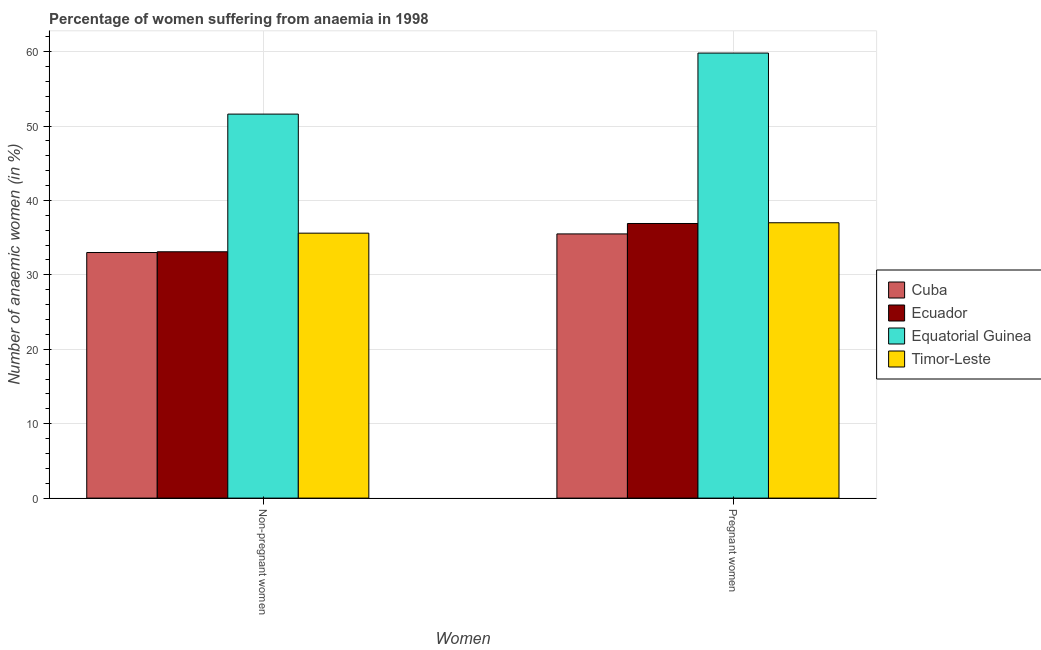How many different coloured bars are there?
Ensure brevity in your answer.  4. How many groups of bars are there?
Provide a succinct answer. 2. Are the number of bars per tick equal to the number of legend labels?
Offer a terse response. Yes. How many bars are there on the 1st tick from the right?
Your answer should be compact. 4. What is the label of the 2nd group of bars from the left?
Give a very brief answer. Pregnant women. Across all countries, what is the maximum percentage of non-pregnant anaemic women?
Provide a succinct answer. 51.6. Across all countries, what is the minimum percentage of non-pregnant anaemic women?
Keep it short and to the point. 33. In which country was the percentage of pregnant anaemic women maximum?
Make the answer very short. Equatorial Guinea. In which country was the percentage of non-pregnant anaemic women minimum?
Your response must be concise. Cuba. What is the total percentage of non-pregnant anaemic women in the graph?
Offer a very short reply. 153.3. What is the difference between the percentage of pregnant anaemic women in Ecuador and that in Timor-Leste?
Provide a succinct answer. -0.1. What is the difference between the percentage of pregnant anaemic women in Equatorial Guinea and the percentage of non-pregnant anaemic women in Ecuador?
Your answer should be compact. 26.7. What is the average percentage of pregnant anaemic women per country?
Provide a short and direct response. 42.3. What is the difference between the percentage of non-pregnant anaemic women and percentage of pregnant anaemic women in Timor-Leste?
Your answer should be compact. -1.4. What is the ratio of the percentage of non-pregnant anaemic women in Equatorial Guinea to that in Ecuador?
Make the answer very short. 1.56. What does the 2nd bar from the left in Pregnant women represents?
Keep it short and to the point. Ecuador. What does the 4th bar from the right in Non-pregnant women represents?
Provide a short and direct response. Cuba. How many countries are there in the graph?
Keep it short and to the point. 4. What is the difference between two consecutive major ticks on the Y-axis?
Provide a short and direct response. 10. Does the graph contain grids?
Offer a terse response. Yes. Where does the legend appear in the graph?
Ensure brevity in your answer.  Center right. How many legend labels are there?
Ensure brevity in your answer.  4. How are the legend labels stacked?
Provide a short and direct response. Vertical. What is the title of the graph?
Offer a very short reply. Percentage of women suffering from anaemia in 1998. What is the label or title of the X-axis?
Provide a short and direct response. Women. What is the label or title of the Y-axis?
Provide a short and direct response. Number of anaemic women (in %). What is the Number of anaemic women (in %) of Cuba in Non-pregnant women?
Offer a very short reply. 33. What is the Number of anaemic women (in %) in Ecuador in Non-pregnant women?
Offer a terse response. 33.1. What is the Number of anaemic women (in %) of Equatorial Guinea in Non-pregnant women?
Ensure brevity in your answer.  51.6. What is the Number of anaemic women (in %) of Timor-Leste in Non-pregnant women?
Offer a terse response. 35.6. What is the Number of anaemic women (in %) in Cuba in Pregnant women?
Keep it short and to the point. 35.5. What is the Number of anaemic women (in %) in Ecuador in Pregnant women?
Your response must be concise. 36.9. What is the Number of anaemic women (in %) of Equatorial Guinea in Pregnant women?
Ensure brevity in your answer.  59.8. Across all Women, what is the maximum Number of anaemic women (in %) in Cuba?
Your answer should be very brief. 35.5. Across all Women, what is the maximum Number of anaemic women (in %) in Ecuador?
Keep it short and to the point. 36.9. Across all Women, what is the maximum Number of anaemic women (in %) of Equatorial Guinea?
Provide a succinct answer. 59.8. Across all Women, what is the minimum Number of anaemic women (in %) in Cuba?
Make the answer very short. 33. Across all Women, what is the minimum Number of anaemic women (in %) of Ecuador?
Provide a short and direct response. 33.1. Across all Women, what is the minimum Number of anaemic women (in %) of Equatorial Guinea?
Offer a very short reply. 51.6. Across all Women, what is the minimum Number of anaemic women (in %) in Timor-Leste?
Ensure brevity in your answer.  35.6. What is the total Number of anaemic women (in %) in Cuba in the graph?
Ensure brevity in your answer.  68.5. What is the total Number of anaemic women (in %) in Equatorial Guinea in the graph?
Provide a short and direct response. 111.4. What is the total Number of anaemic women (in %) in Timor-Leste in the graph?
Ensure brevity in your answer.  72.6. What is the difference between the Number of anaemic women (in %) of Cuba in Non-pregnant women and that in Pregnant women?
Provide a short and direct response. -2.5. What is the difference between the Number of anaemic women (in %) in Ecuador in Non-pregnant women and that in Pregnant women?
Provide a short and direct response. -3.8. What is the difference between the Number of anaemic women (in %) of Timor-Leste in Non-pregnant women and that in Pregnant women?
Provide a short and direct response. -1.4. What is the difference between the Number of anaemic women (in %) in Cuba in Non-pregnant women and the Number of anaemic women (in %) in Equatorial Guinea in Pregnant women?
Give a very brief answer. -26.8. What is the difference between the Number of anaemic women (in %) in Cuba in Non-pregnant women and the Number of anaemic women (in %) in Timor-Leste in Pregnant women?
Your response must be concise. -4. What is the difference between the Number of anaemic women (in %) in Ecuador in Non-pregnant women and the Number of anaemic women (in %) in Equatorial Guinea in Pregnant women?
Offer a terse response. -26.7. What is the average Number of anaemic women (in %) of Cuba per Women?
Offer a terse response. 34.25. What is the average Number of anaemic women (in %) of Ecuador per Women?
Make the answer very short. 35. What is the average Number of anaemic women (in %) in Equatorial Guinea per Women?
Your response must be concise. 55.7. What is the average Number of anaemic women (in %) in Timor-Leste per Women?
Offer a terse response. 36.3. What is the difference between the Number of anaemic women (in %) of Cuba and Number of anaemic women (in %) of Ecuador in Non-pregnant women?
Provide a succinct answer. -0.1. What is the difference between the Number of anaemic women (in %) of Cuba and Number of anaemic women (in %) of Equatorial Guinea in Non-pregnant women?
Provide a short and direct response. -18.6. What is the difference between the Number of anaemic women (in %) of Cuba and Number of anaemic women (in %) of Timor-Leste in Non-pregnant women?
Provide a succinct answer. -2.6. What is the difference between the Number of anaemic women (in %) in Ecuador and Number of anaemic women (in %) in Equatorial Guinea in Non-pregnant women?
Offer a very short reply. -18.5. What is the difference between the Number of anaemic women (in %) in Ecuador and Number of anaemic women (in %) in Timor-Leste in Non-pregnant women?
Provide a succinct answer. -2.5. What is the difference between the Number of anaemic women (in %) in Cuba and Number of anaemic women (in %) in Ecuador in Pregnant women?
Make the answer very short. -1.4. What is the difference between the Number of anaemic women (in %) in Cuba and Number of anaemic women (in %) in Equatorial Guinea in Pregnant women?
Ensure brevity in your answer.  -24.3. What is the difference between the Number of anaemic women (in %) of Ecuador and Number of anaemic women (in %) of Equatorial Guinea in Pregnant women?
Offer a terse response. -22.9. What is the difference between the Number of anaemic women (in %) in Ecuador and Number of anaemic women (in %) in Timor-Leste in Pregnant women?
Your answer should be very brief. -0.1. What is the difference between the Number of anaemic women (in %) in Equatorial Guinea and Number of anaemic women (in %) in Timor-Leste in Pregnant women?
Offer a very short reply. 22.8. What is the ratio of the Number of anaemic women (in %) of Cuba in Non-pregnant women to that in Pregnant women?
Give a very brief answer. 0.93. What is the ratio of the Number of anaemic women (in %) of Ecuador in Non-pregnant women to that in Pregnant women?
Give a very brief answer. 0.9. What is the ratio of the Number of anaemic women (in %) in Equatorial Guinea in Non-pregnant women to that in Pregnant women?
Provide a succinct answer. 0.86. What is the ratio of the Number of anaemic women (in %) of Timor-Leste in Non-pregnant women to that in Pregnant women?
Your answer should be compact. 0.96. What is the difference between the highest and the second highest Number of anaemic women (in %) in Cuba?
Offer a terse response. 2.5. What is the difference between the highest and the lowest Number of anaemic women (in %) of Ecuador?
Ensure brevity in your answer.  3.8. What is the difference between the highest and the lowest Number of anaemic women (in %) in Timor-Leste?
Make the answer very short. 1.4. 